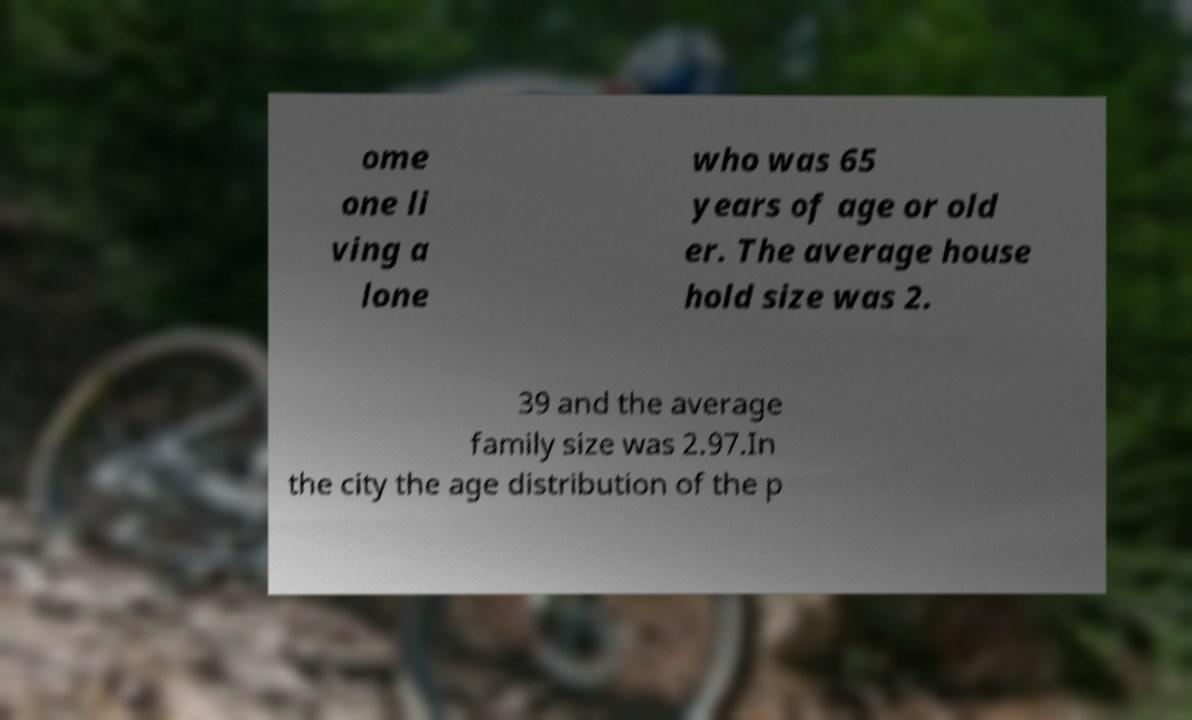What messages or text are displayed in this image? I need them in a readable, typed format. ome one li ving a lone who was 65 years of age or old er. The average house hold size was 2. 39 and the average family size was 2.97.In the city the age distribution of the p 